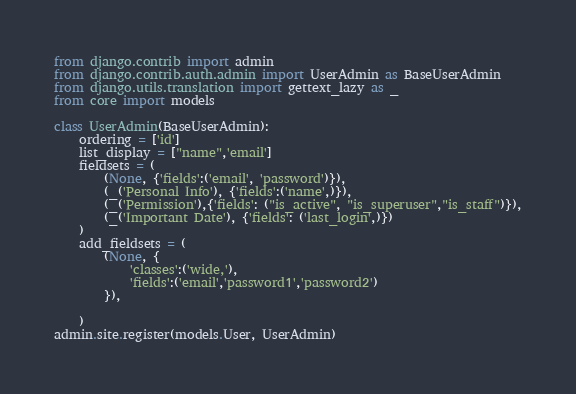Convert code to text. <code><loc_0><loc_0><loc_500><loc_500><_Python_>from django.contrib import admin
from django.contrib.auth.admin import UserAdmin as BaseUserAdmin
from django.utils.translation import gettext_lazy as _
from core import models

class UserAdmin(BaseUserAdmin):
    ordering = ['id']
    list_display = ["name",'email']
    fieldsets = (
        (None, {'fields':('email', 'password')}),
        (_('Personal Info'), {'fields':('name',)}),
        (_('Permission'),{'fields': ("is_active", "is_superuser","is_staff")}),
        (_('Important Date'), {'fields': ('last_login',)})
    )
    add_fieldsets = (
        (None, {
            'classes':('wide,'),
            'fields':('email','password1','password2')
        }),
         
    )
admin.site.register(models.User, UserAdmin)</code> 